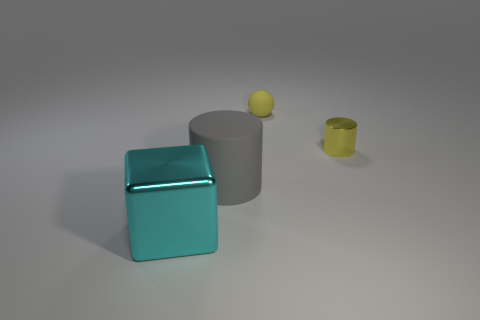What number of yellow things are in front of the small ball and behind the yellow metal cylinder?
Ensure brevity in your answer.  0. What is the material of the cyan block?
Your answer should be compact. Metal. Are any yellow rubber blocks visible?
Provide a short and direct response. No. What color is the thing in front of the large matte object?
Ensure brevity in your answer.  Cyan. There is a big thing left of the large thing that is behind the big cyan cube; what number of big metallic blocks are in front of it?
Keep it short and to the point. 0. There is a thing that is both on the right side of the large matte thing and to the left of the shiny cylinder; what is it made of?
Ensure brevity in your answer.  Rubber. Do the big cylinder and the object that is on the left side of the gray rubber cylinder have the same material?
Your answer should be very brief. No. Are there more big gray objects on the right side of the small yellow metal cylinder than small yellow matte spheres behind the gray rubber cylinder?
Keep it short and to the point. No. The cyan object is what shape?
Provide a succinct answer. Cube. Is the cylinder behind the big gray thing made of the same material as the large thing in front of the gray rubber object?
Offer a very short reply. Yes. 